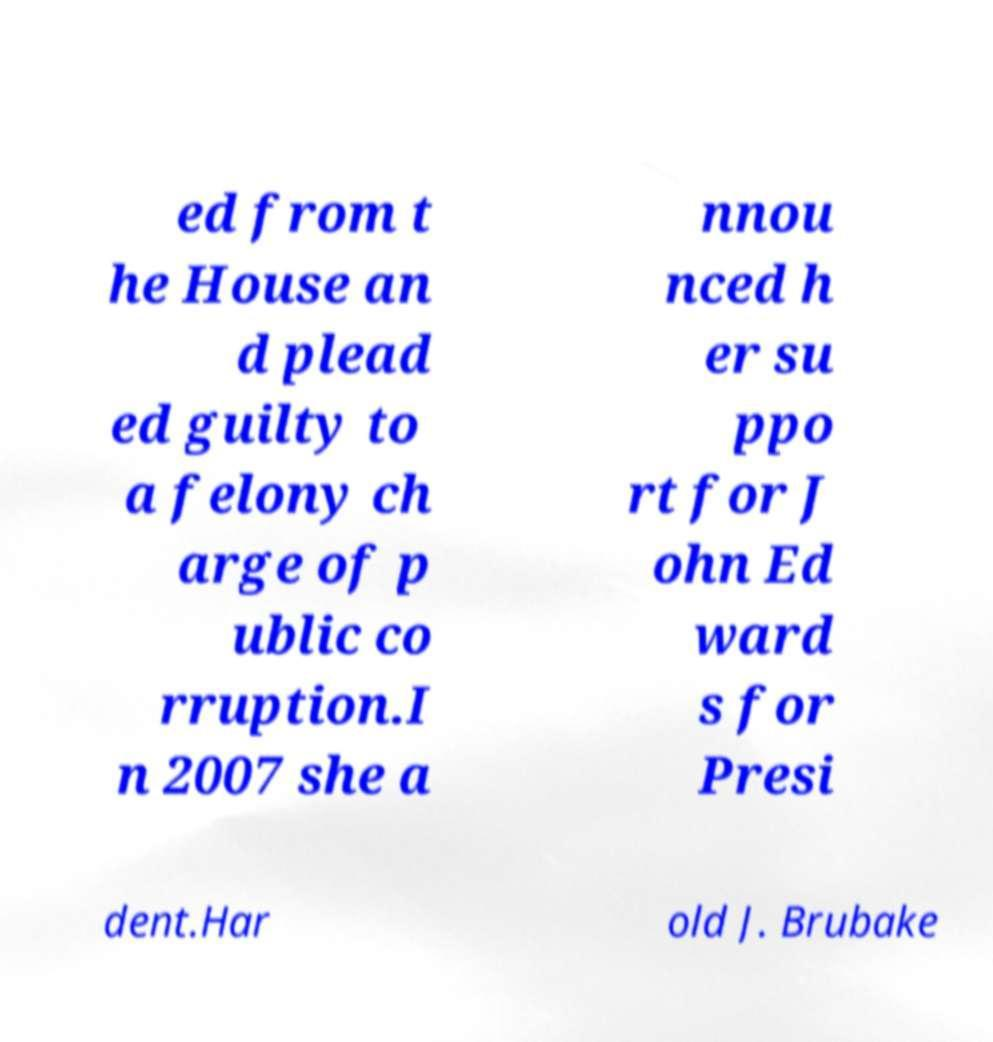Please identify and transcribe the text found in this image. ed from t he House an d plead ed guilty to a felony ch arge of p ublic co rruption.I n 2007 she a nnou nced h er su ppo rt for J ohn Ed ward s for Presi dent.Har old J. Brubake 